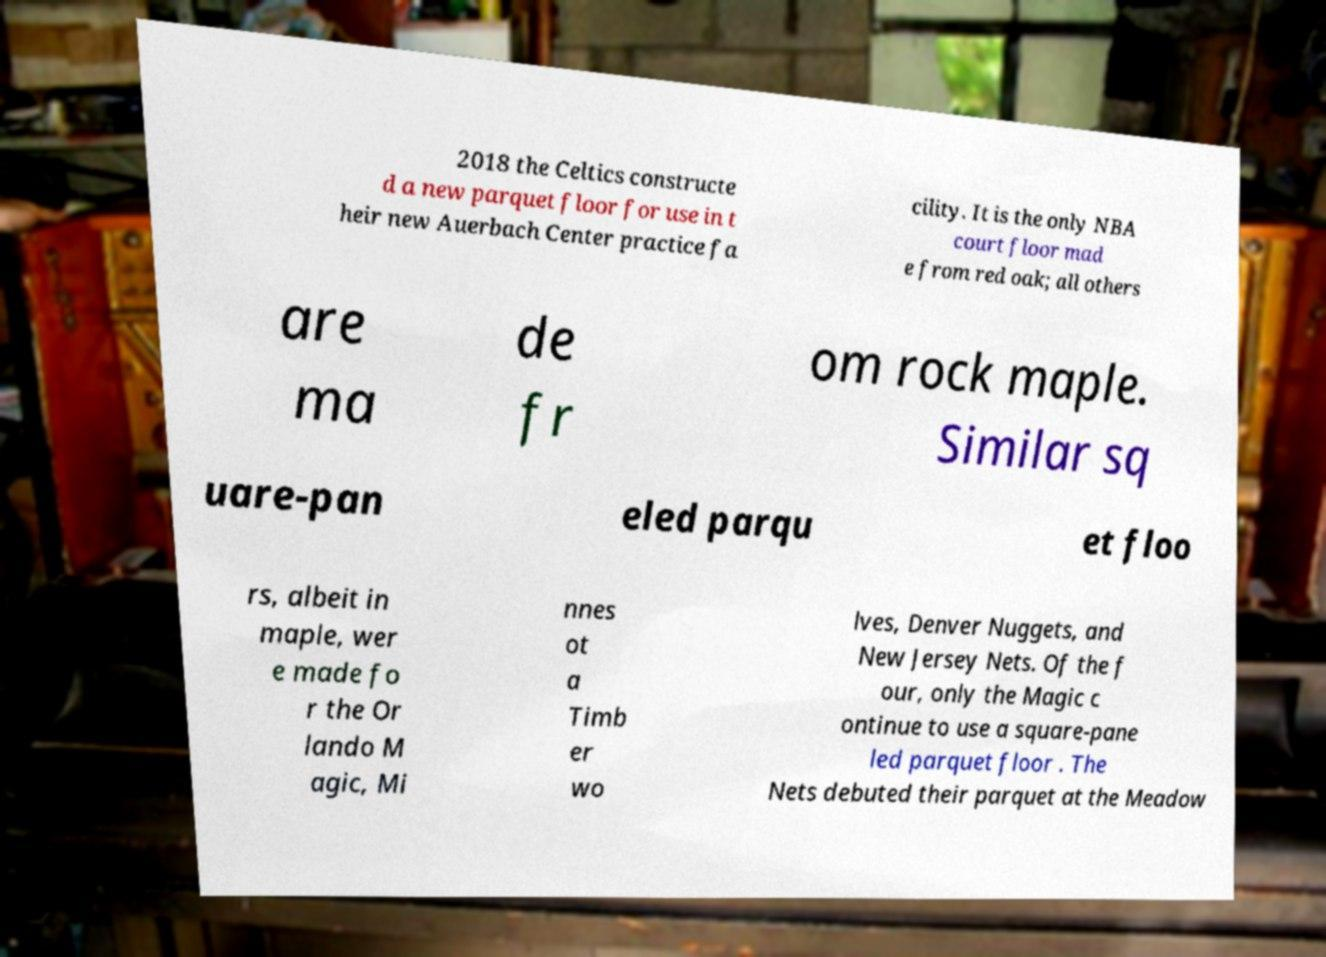Could you extract and type out the text from this image? 2018 the Celtics constructe d a new parquet floor for use in t heir new Auerbach Center practice fa cility. It is the only NBA court floor mad e from red oak; all others are ma de fr om rock maple. Similar sq uare-pan eled parqu et floo rs, albeit in maple, wer e made fo r the Or lando M agic, Mi nnes ot a Timb er wo lves, Denver Nuggets, and New Jersey Nets. Of the f our, only the Magic c ontinue to use a square-pane led parquet floor . The Nets debuted their parquet at the Meadow 